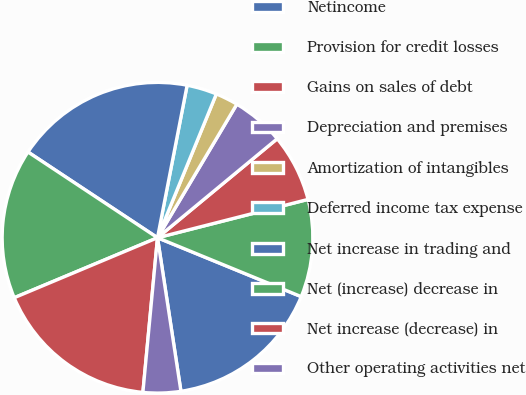<chart> <loc_0><loc_0><loc_500><loc_500><pie_chart><fcel>Netincome<fcel>Provision for credit losses<fcel>Gains on sales of debt<fcel>Depreciation and premises<fcel>Amortization of intangibles<fcel>Deferred income tax expense<fcel>Net increase in trading and<fcel>Net (increase) decrease in<fcel>Net increase (decrease) in<fcel>Other operating activities net<nl><fcel>16.4%<fcel>10.16%<fcel>7.03%<fcel>5.47%<fcel>2.35%<fcel>3.13%<fcel>18.75%<fcel>15.62%<fcel>17.19%<fcel>3.91%<nl></chart> 